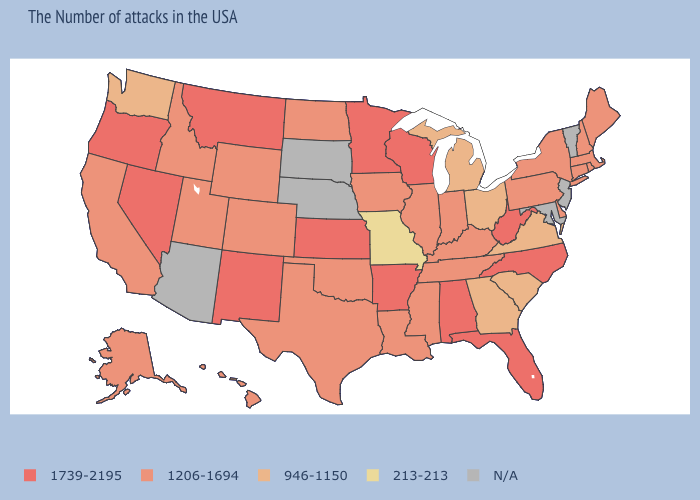What is the highest value in states that border Washington?
Answer briefly. 1739-2195. Name the states that have a value in the range N/A?
Keep it brief. Vermont, New Jersey, Maryland, Nebraska, South Dakota, Arizona. Among the states that border South Carolina , which have the highest value?
Be succinct. North Carolina. What is the value of New York?
Quick response, please. 1206-1694. Which states hav the highest value in the Northeast?
Quick response, please. Maine, Massachusetts, Rhode Island, New Hampshire, Connecticut, New York, Pennsylvania. What is the value of Wisconsin?
Write a very short answer. 1739-2195. Does California have the highest value in the USA?
Concise answer only. No. Name the states that have a value in the range 213-213?
Concise answer only. Missouri. What is the lowest value in the Northeast?
Write a very short answer. 1206-1694. What is the value of Tennessee?
Answer briefly. 1206-1694. Name the states that have a value in the range 1206-1694?
Keep it brief. Maine, Massachusetts, Rhode Island, New Hampshire, Connecticut, New York, Delaware, Pennsylvania, Kentucky, Indiana, Tennessee, Illinois, Mississippi, Louisiana, Iowa, Oklahoma, Texas, North Dakota, Wyoming, Colorado, Utah, Idaho, California, Alaska, Hawaii. What is the highest value in the USA?
Quick response, please. 1739-2195. What is the lowest value in states that border Texas?
Write a very short answer. 1206-1694. What is the value of Louisiana?
Keep it brief. 1206-1694. 